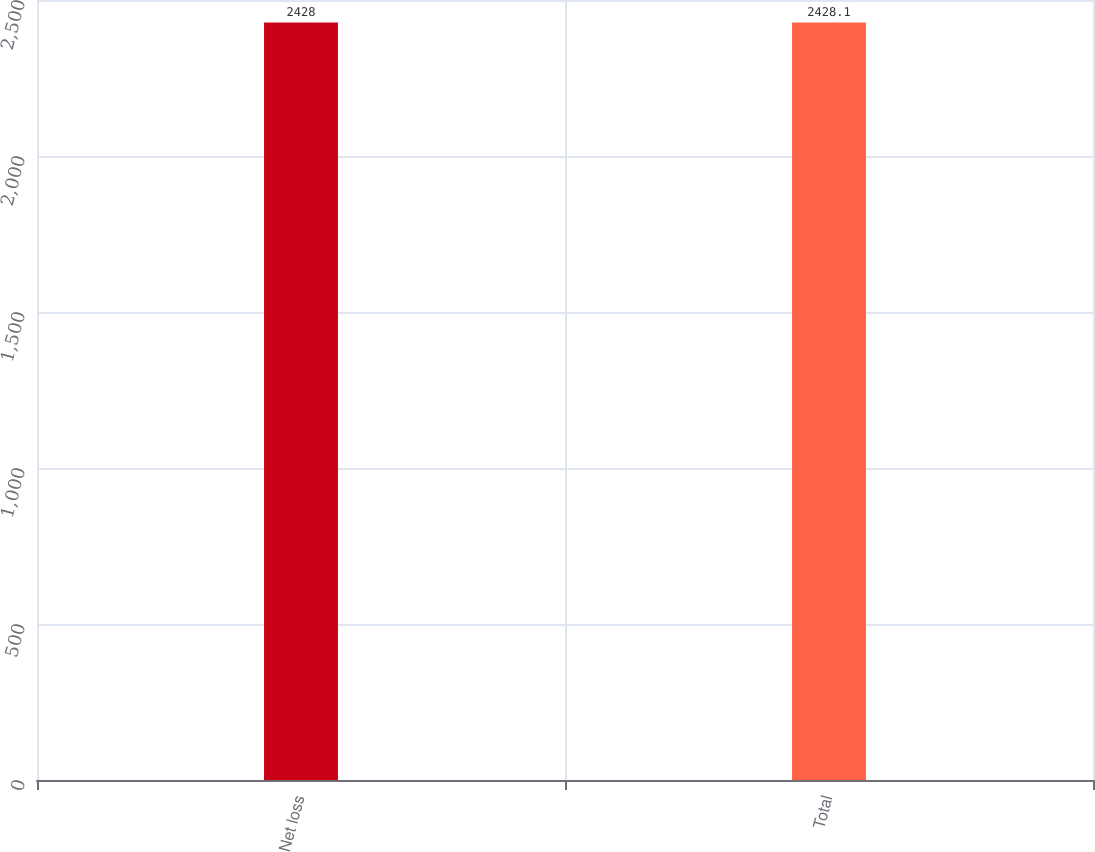Convert chart. <chart><loc_0><loc_0><loc_500><loc_500><bar_chart><fcel>Net loss<fcel>Total<nl><fcel>2428<fcel>2428.1<nl></chart> 